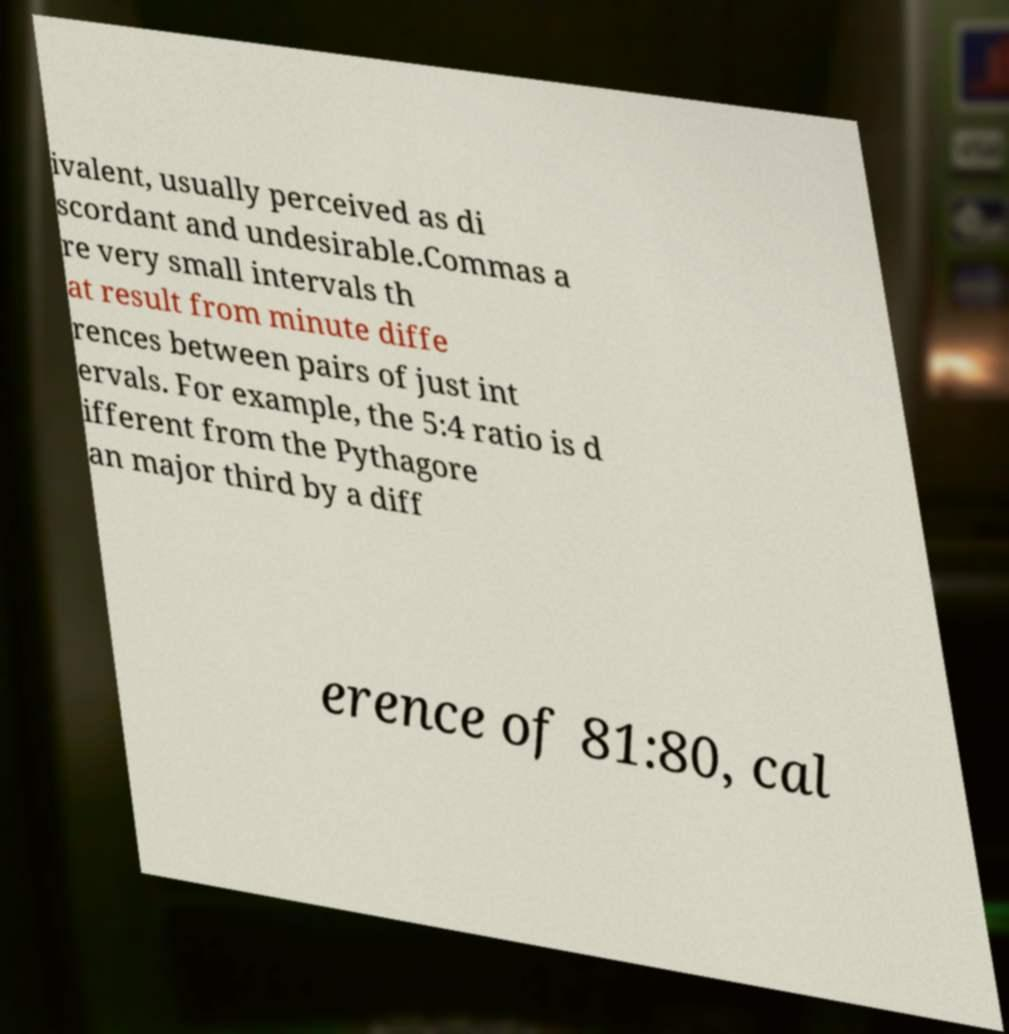Could you assist in decoding the text presented in this image and type it out clearly? ivalent, usually perceived as di scordant and undesirable.Commas a re very small intervals th at result from minute diffe rences between pairs of just int ervals. For example, the 5:4 ratio is d ifferent from the Pythagore an major third by a diff erence of 81:80, cal 